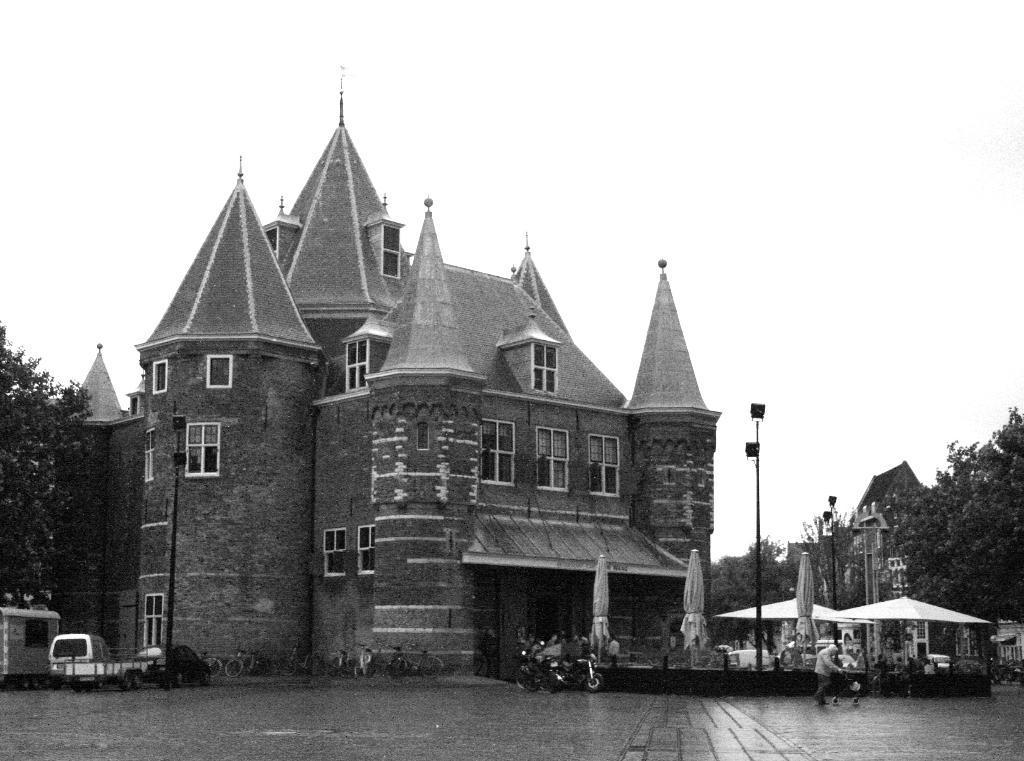Please provide a concise description of this image. In this picture there is a building in the center of the image, on which there are windows and there are cars at the bottom side of the image, there are trees on the right and left side of the image. 